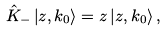<formula> <loc_0><loc_0><loc_500><loc_500>\hat { K } _ { - } \left | z , k _ { 0 } \right > = z \left | z , k _ { 0 } \right > ,</formula> 